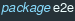<code> <loc_0><loc_0><loc_500><loc_500><_Go_>package e2e
</code> 